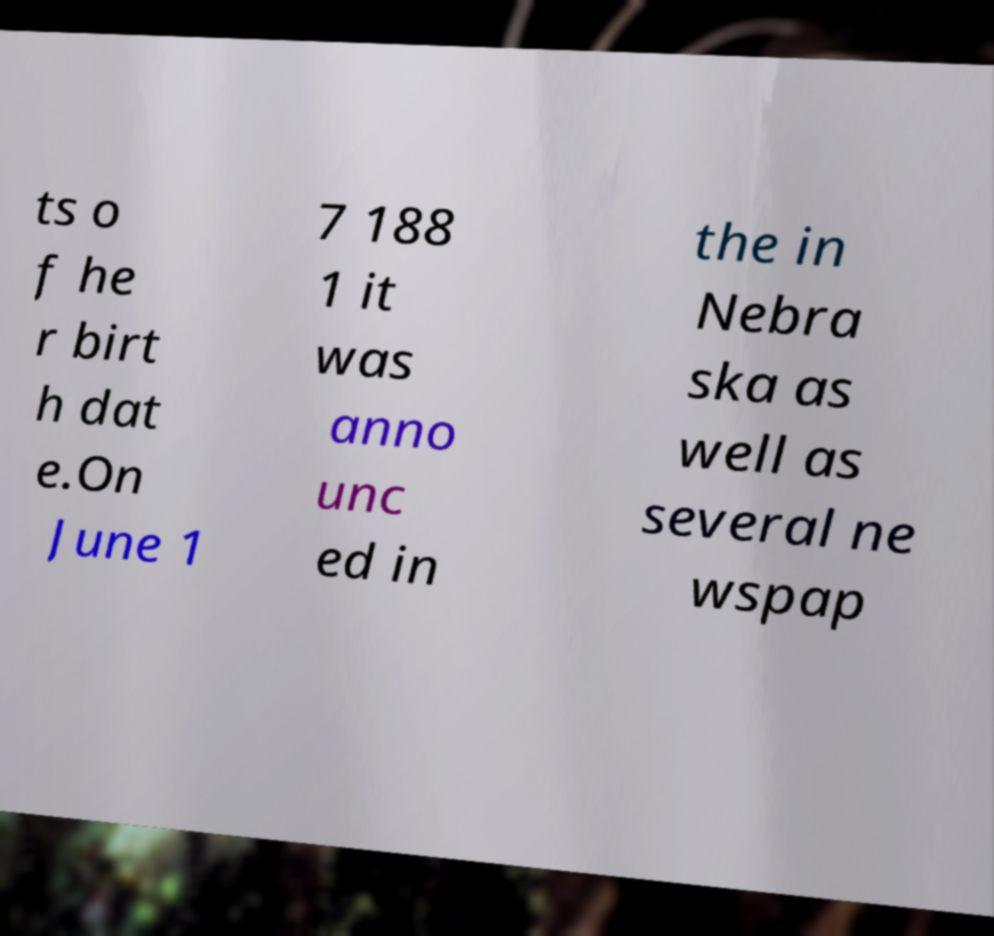For documentation purposes, I need the text within this image transcribed. Could you provide that? ts o f he r birt h dat e.On June 1 7 188 1 it was anno unc ed in the in Nebra ska as well as several ne wspap 